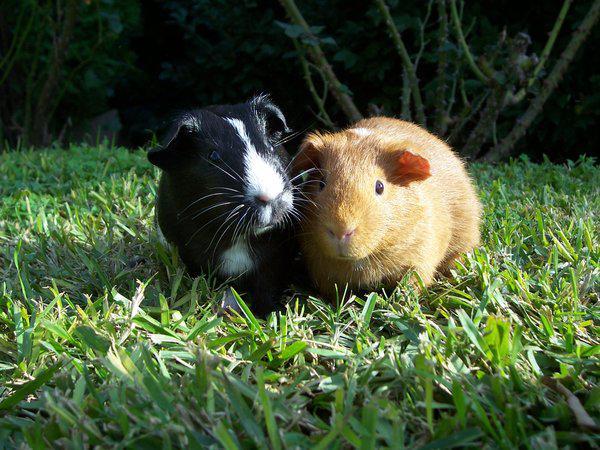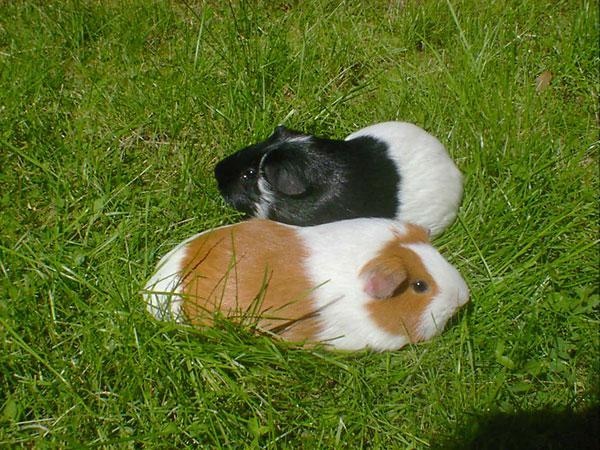The first image is the image on the left, the second image is the image on the right. For the images displayed, is the sentence "Two rodents are sitting together in the grass in each of the images." factually correct? Answer yes or no. Yes. The first image is the image on the left, the second image is the image on the right. For the images displayed, is the sentence "Each image shows exactly one side-by-side pair of guinea pigs posed outdoors on green ground." factually correct? Answer yes or no. Yes. 